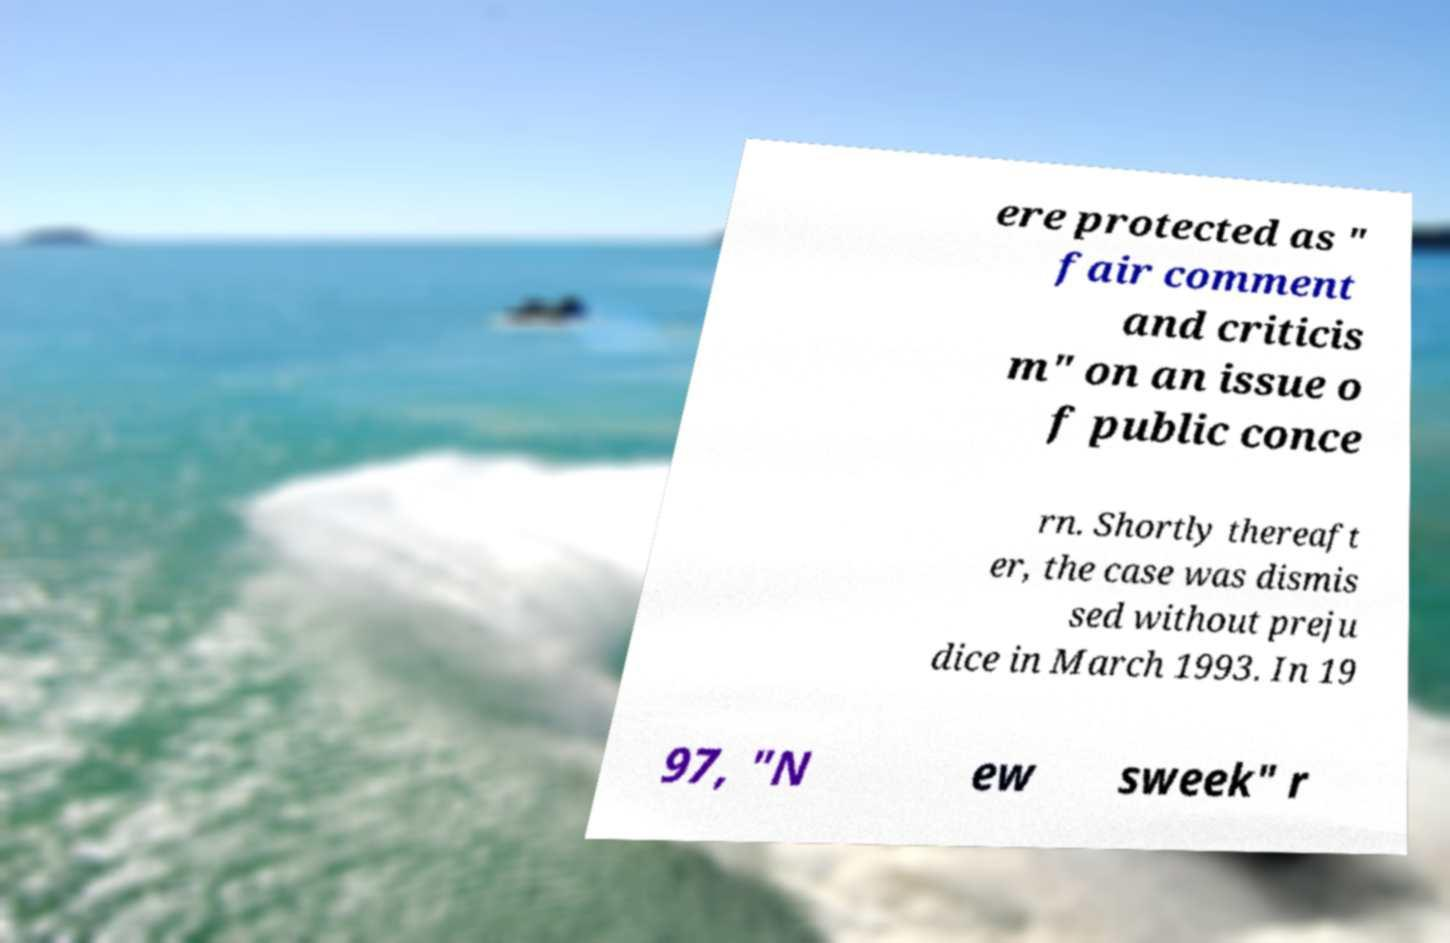Please identify and transcribe the text found in this image. ere protected as " fair comment and criticis m" on an issue o f public conce rn. Shortly thereaft er, the case was dismis sed without preju dice in March 1993. In 19 97, "N ew sweek" r 